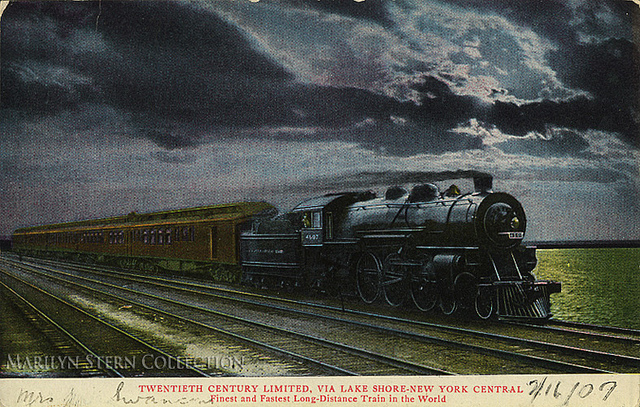Please transcribe the text information in this image. TWENTIETH CENTURY LIMITED VIA LAKE 107 16 7 CENTRAL World the in YORK NEW SHORE Train Distance Long- Fastest and Finest TWENTIETH Mr COLLECTION STERN MARILYN 